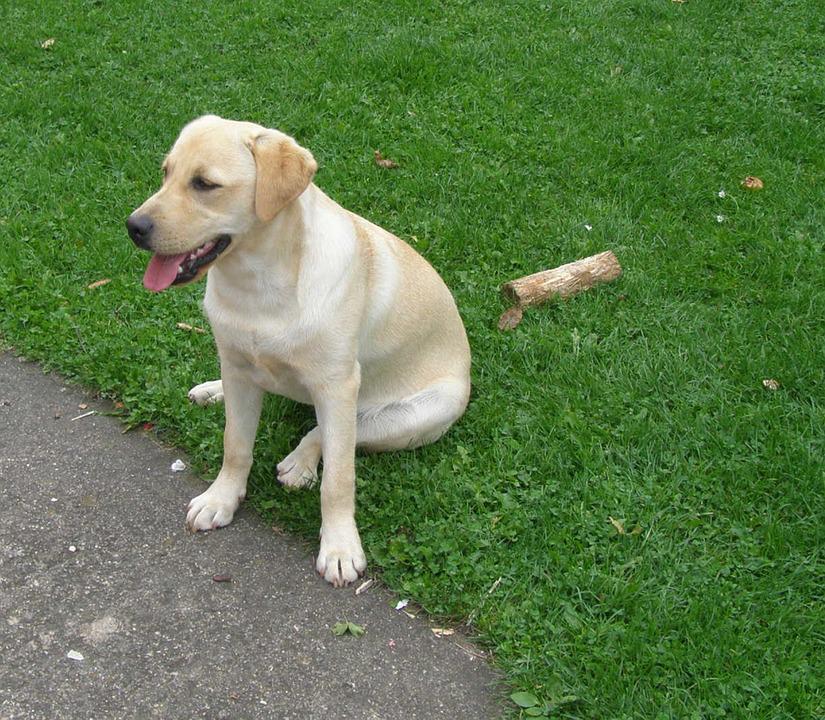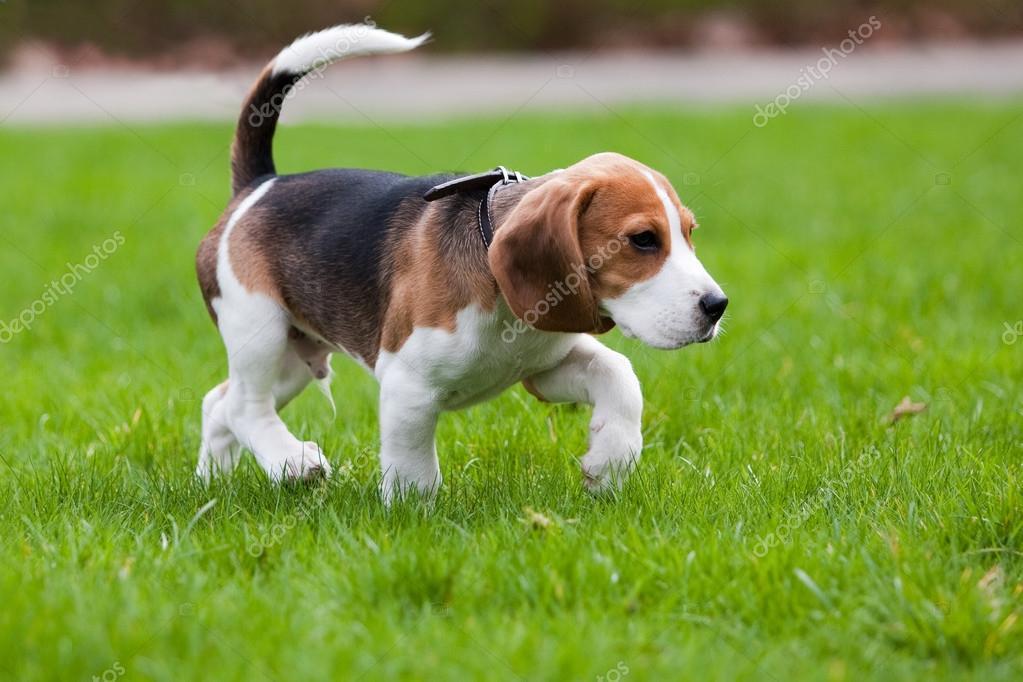The first image is the image on the left, the second image is the image on the right. Given the left and right images, does the statement "A large stick-like object is on the grass near a dog in one image." hold true? Answer yes or no. Yes. 